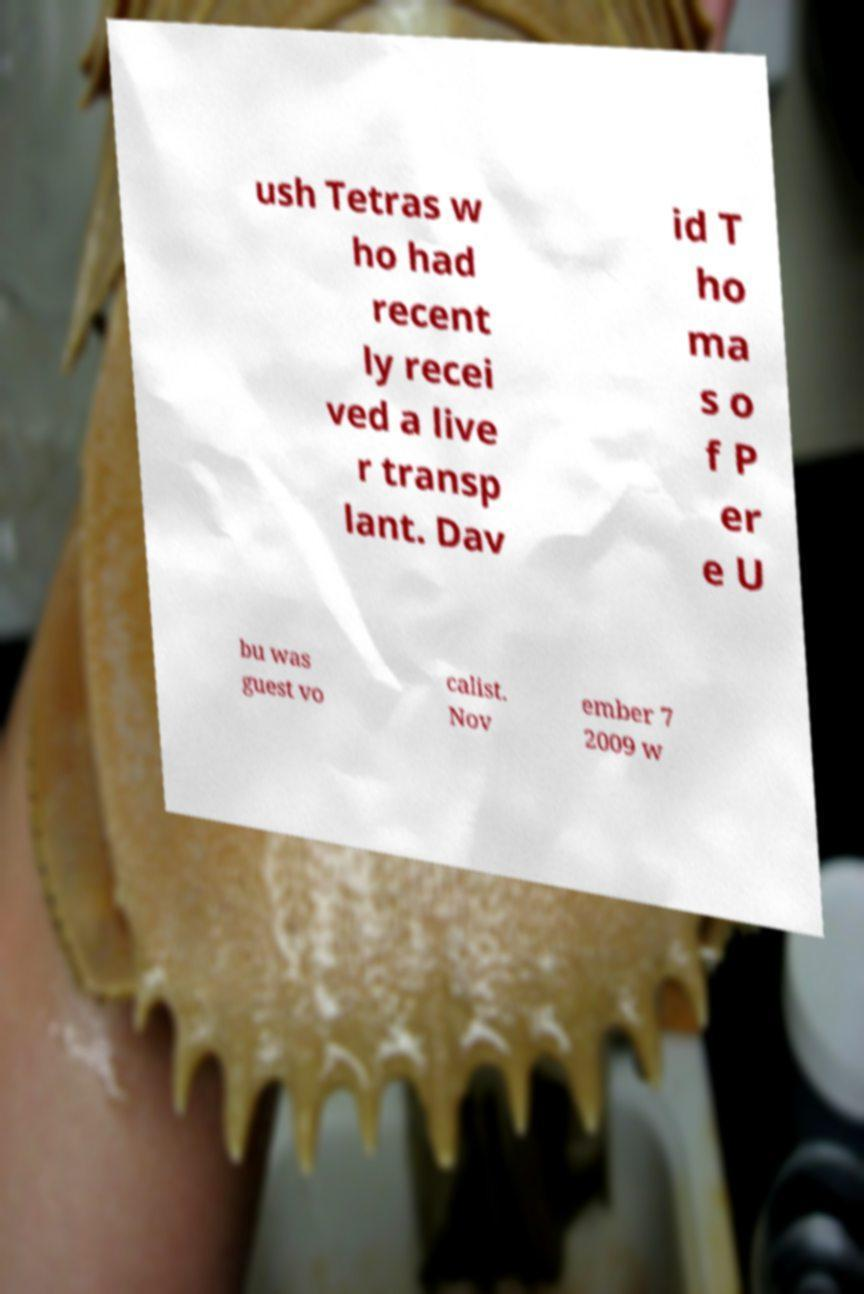Can you read and provide the text displayed in the image?This photo seems to have some interesting text. Can you extract and type it out for me? ush Tetras w ho had recent ly recei ved a live r transp lant. Dav id T ho ma s o f P er e U bu was guest vo calist. Nov ember 7 2009 w 